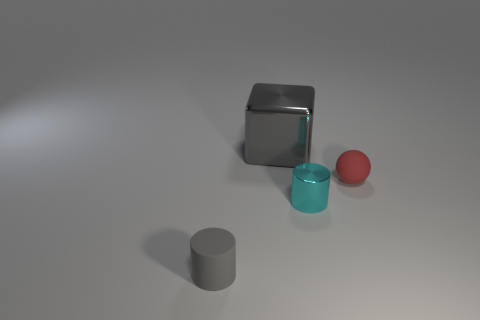There is a small matte object in front of the small cyan shiny cylinder; is it the same shape as the cyan shiny thing?
Provide a succinct answer. Yes. Is the number of red spheres in front of the small metallic cylinder less than the number of blocks that are behind the big gray block?
Provide a succinct answer. No. What is the size of the gray thing right of the cylinder that is in front of the shiny object that is on the right side of the large thing?
Offer a very short reply. Large. There is a cylinder right of the gray cylinder; is its size the same as the red matte thing?
Your answer should be compact. Yes. What number of other objects are the same material as the tiny ball?
Provide a succinct answer. 1. Are there more big gray shiny things than tiny yellow metallic balls?
Provide a succinct answer. Yes. The gray thing behind the small thing that is to the right of the metal object in front of the metal block is made of what material?
Keep it short and to the point. Metal. Does the big metal block have the same color as the ball?
Ensure brevity in your answer.  No. Is there a cube that has the same color as the small sphere?
Ensure brevity in your answer.  No. What shape is the gray thing that is the same size as the cyan metal object?
Your answer should be very brief. Cylinder. 